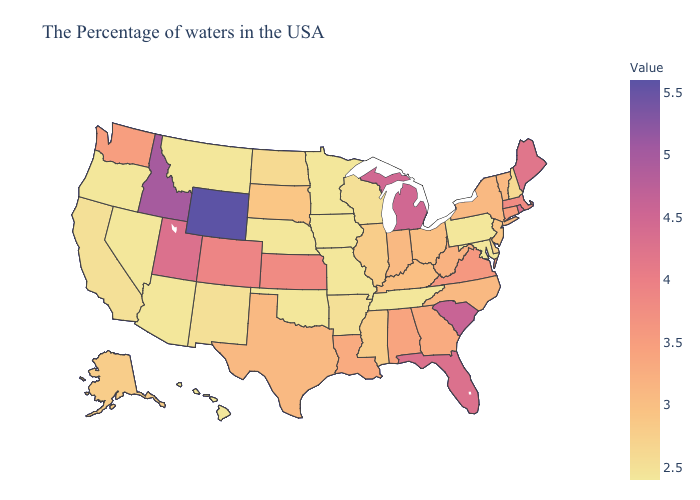Does Ohio have the lowest value in the MidWest?
Short answer required. No. Which states have the highest value in the USA?
Keep it brief. Wyoming. Does Louisiana have a higher value than Alaska?
Keep it brief. Yes. 